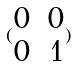<formula> <loc_0><loc_0><loc_500><loc_500>( \begin{matrix} 0 & 0 \\ 0 & 1 \end{matrix} )</formula> 